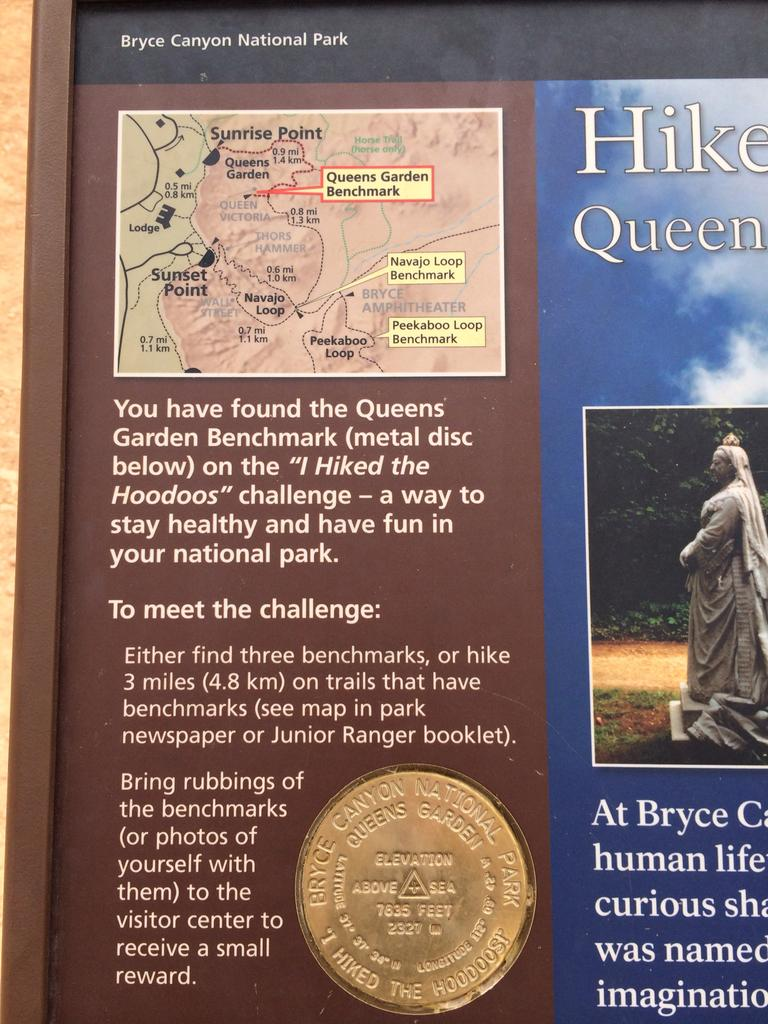<image>
Write a terse but informative summary of the picture. A map on a board that shows the sunrise and sunset points. 